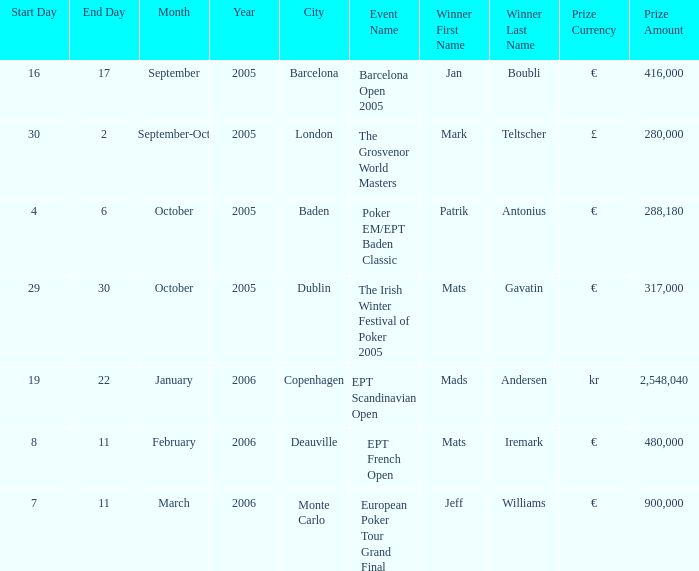When was the event in Dublin? 29–30 October 2005. Could you help me parse every detail presented in this table? {'header': ['Start Day', 'End Day', 'Month', 'Year', 'City', 'Event Name', 'Winner First Name', 'Winner Last Name', 'Prize Currency', 'Prize Amount'], 'rows': [['16', '17', 'September', '2005', 'Barcelona', 'Barcelona Open 2005', 'Jan', 'Boubli', '€', '416,000'], ['30', '2', 'September-Oct', '2005', 'London', 'The Grosvenor World Masters', 'Mark', 'Teltscher', '£', '280,000'], ['4', '6', 'October', '2005', 'Baden', 'Poker EM/EPT Baden Classic', 'Patrik', 'Antonius', '€', '288,180'], ['29', '30', 'October', '2005', 'Dublin', 'The Irish Winter Festival of Poker 2005', 'Mats', 'Gavatin', '€', '317,000'], ['19', '22', 'January', '2006', 'Copenhagen', 'EPT Scandinavian Open', 'Mads', 'Andersen', 'kr', '2,548,040'], ['8', '11', 'February', '2006', 'Deauville', 'EPT French Open', 'Mats', 'Iremark', '€', '480,000'], ['7', '11', 'March', '2006', 'Monte Carlo', 'European Poker Tour Grand Final', 'Jeff', 'Williams', '€', '900,000']]} 